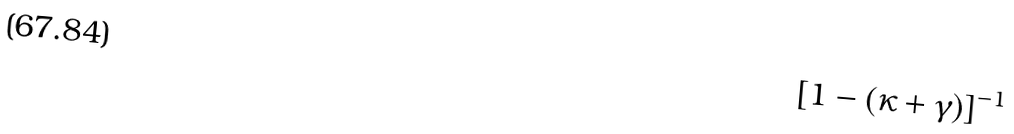<formula> <loc_0><loc_0><loc_500><loc_500>[ 1 - ( \kappa + \gamma ) ] ^ { - 1 }</formula> 